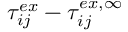<formula> <loc_0><loc_0><loc_500><loc_500>\tau _ { i j } ^ { e x } - \tau _ { i j } ^ { e x , \infty }</formula> 